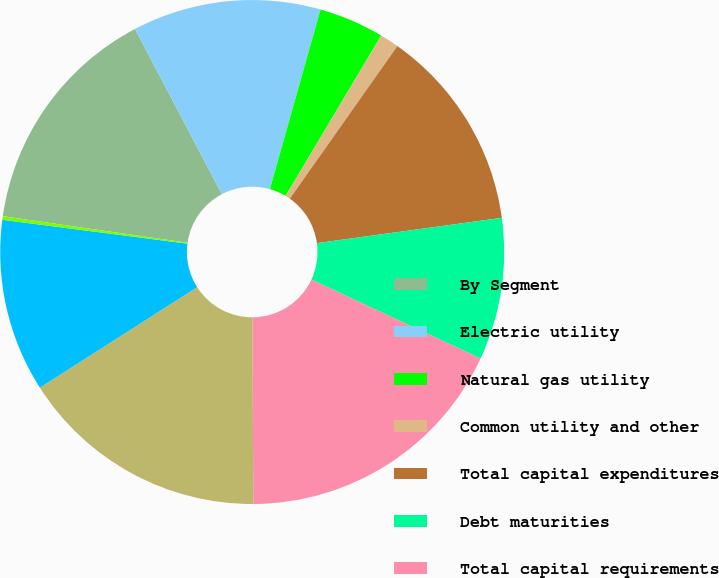Convert chart to OTSL. <chart><loc_0><loc_0><loc_500><loc_500><pie_chart><fcel>By Segment<fcel>Electric utility<fcel>Natural gas utility<fcel>Common utility and other<fcel>Total capital expenditures<fcel>Debt maturities<fcel>Total capital requirements<fcel>By Utility Subsidiary<fcel>NSP-Minnesota<fcel>NSP-Wisconsin<nl><fcel>15.03%<fcel>12.07%<fcel>4.18%<fcel>1.22%<fcel>13.06%<fcel>9.11%<fcel>17.99%<fcel>16.02%<fcel>11.09%<fcel>0.23%<nl></chart> 